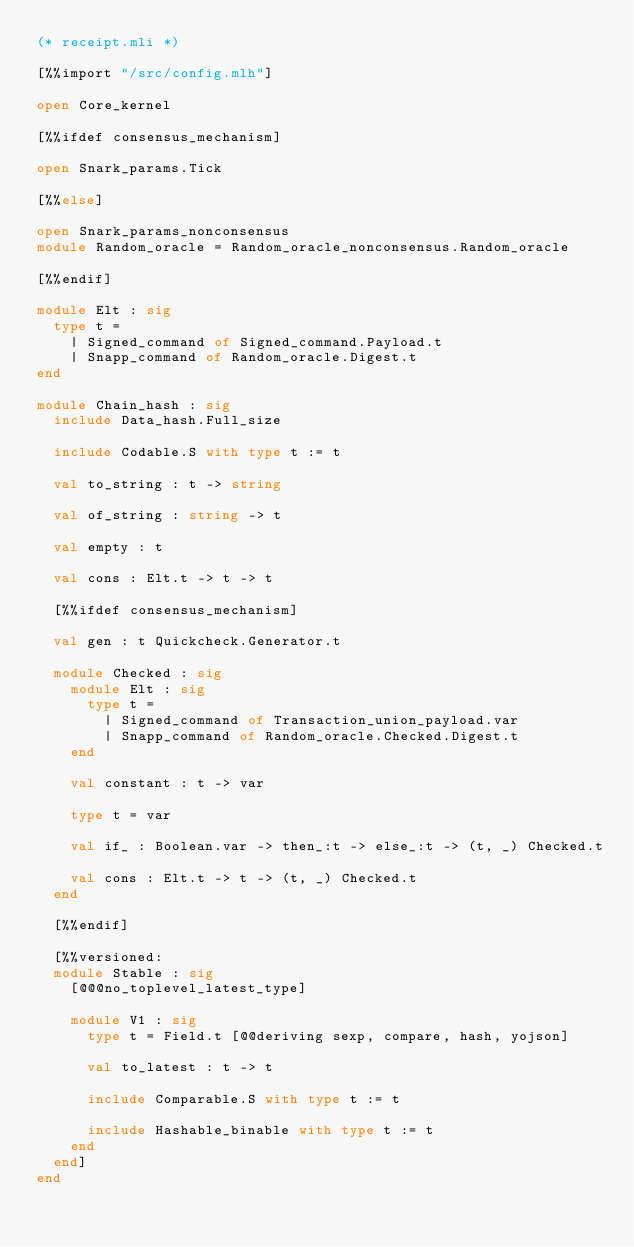<code> <loc_0><loc_0><loc_500><loc_500><_OCaml_>(* receipt.mli *)

[%%import "/src/config.mlh"]

open Core_kernel

[%%ifdef consensus_mechanism]

open Snark_params.Tick

[%%else]

open Snark_params_nonconsensus
module Random_oracle = Random_oracle_nonconsensus.Random_oracle

[%%endif]

module Elt : sig
  type t =
    | Signed_command of Signed_command.Payload.t
    | Snapp_command of Random_oracle.Digest.t
end

module Chain_hash : sig
  include Data_hash.Full_size

  include Codable.S with type t := t

  val to_string : t -> string

  val of_string : string -> t

  val empty : t

  val cons : Elt.t -> t -> t

  [%%ifdef consensus_mechanism]

  val gen : t Quickcheck.Generator.t

  module Checked : sig
    module Elt : sig
      type t =
        | Signed_command of Transaction_union_payload.var
        | Snapp_command of Random_oracle.Checked.Digest.t
    end

    val constant : t -> var

    type t = var

    val if_ : Boolean.var -> then_:t -> else_:t -> (t, _) Checked.t

    val cons : Elt.t -> t -> (t, _) Checked.t
  end

  [%%endif]

  [%%versioned:
  module Stable : sig
    [@@@no_toplevel_latest_type]

    module V1 : sig
      type t = Field.t [@@deriving sexp, compare, hash, yojson]

      val to_latest : t -> t

      include Comparable.S with type t := t

      include Hashable_binable with type t := t
    end
  end]
end
</code> 